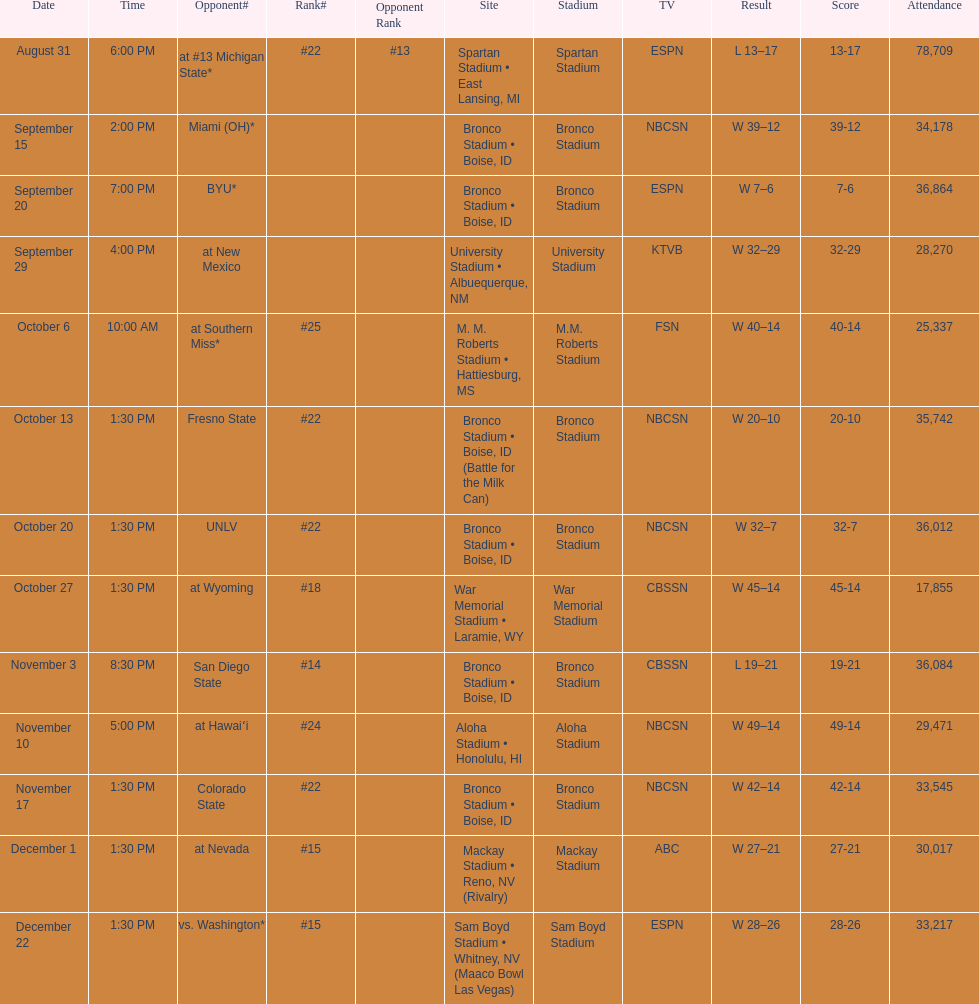What are the opponents to the  2012 boise state broncos football team? At #13 michigan state*, miami (oh)*, byu*, at new mexico, at southern miss*, fresno state, unlv, at wyoming, san diego state, at hawaiʻi, colorado state, at nevada, vs. washington*. Which is the highest ranked of the teams? San Diego State. 